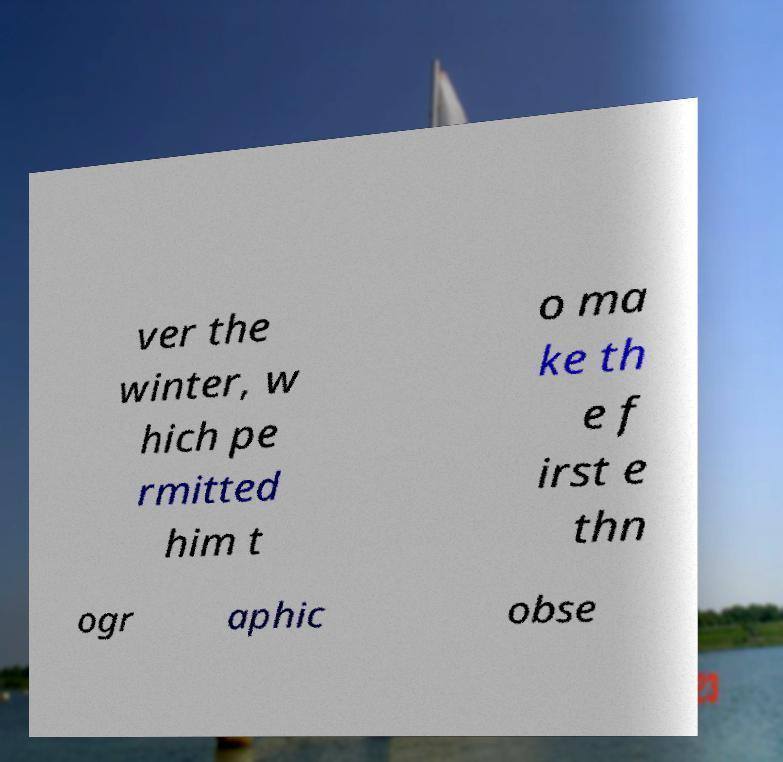Could you extract and type out the text from this image? ver the winter, w hich pe rmitted him t o ma ke th e f irst e thn ogr aphic obse 